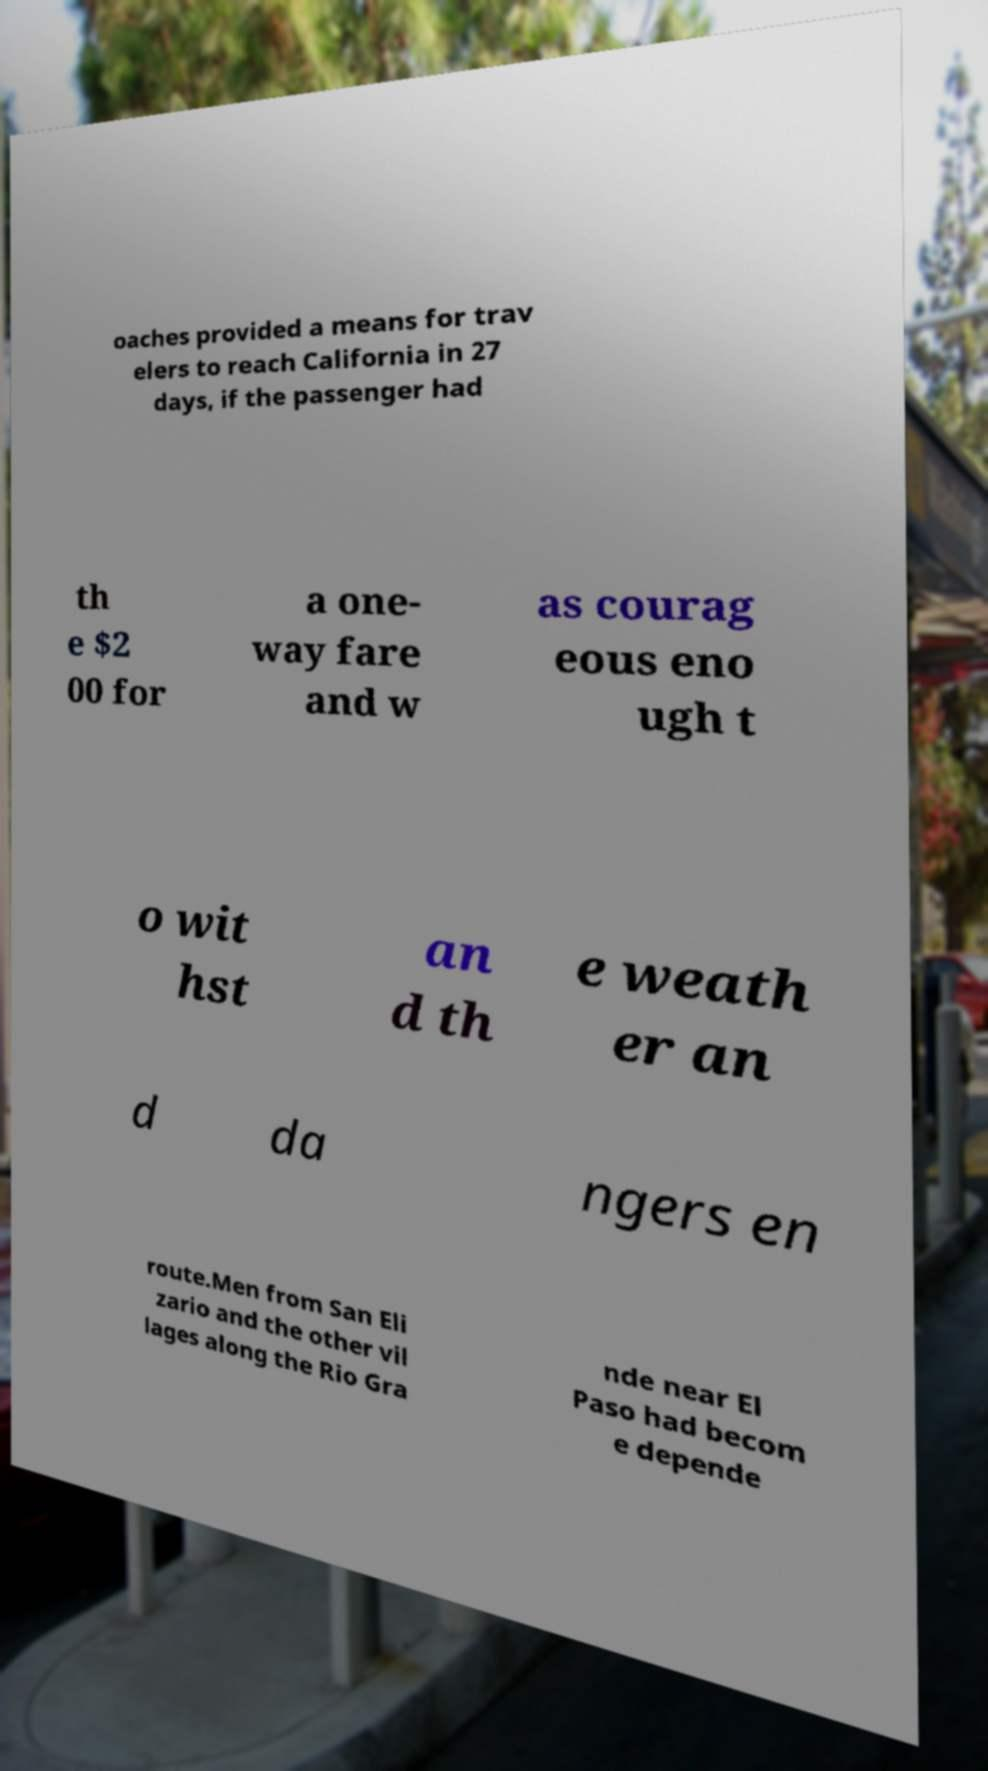Can you accurately transcribe the text from the provided image for me? oaches provided a means for trav elers to reach California in 27 days, if the passenger had th e $2 00 for a one- way fare and w as courag eous eno ugh t o wit hst an d th e weath er an d da ngers en route.Men from San Eli zario and the other vil lages along the Rio Gra nde near El Paso had becom e depende 